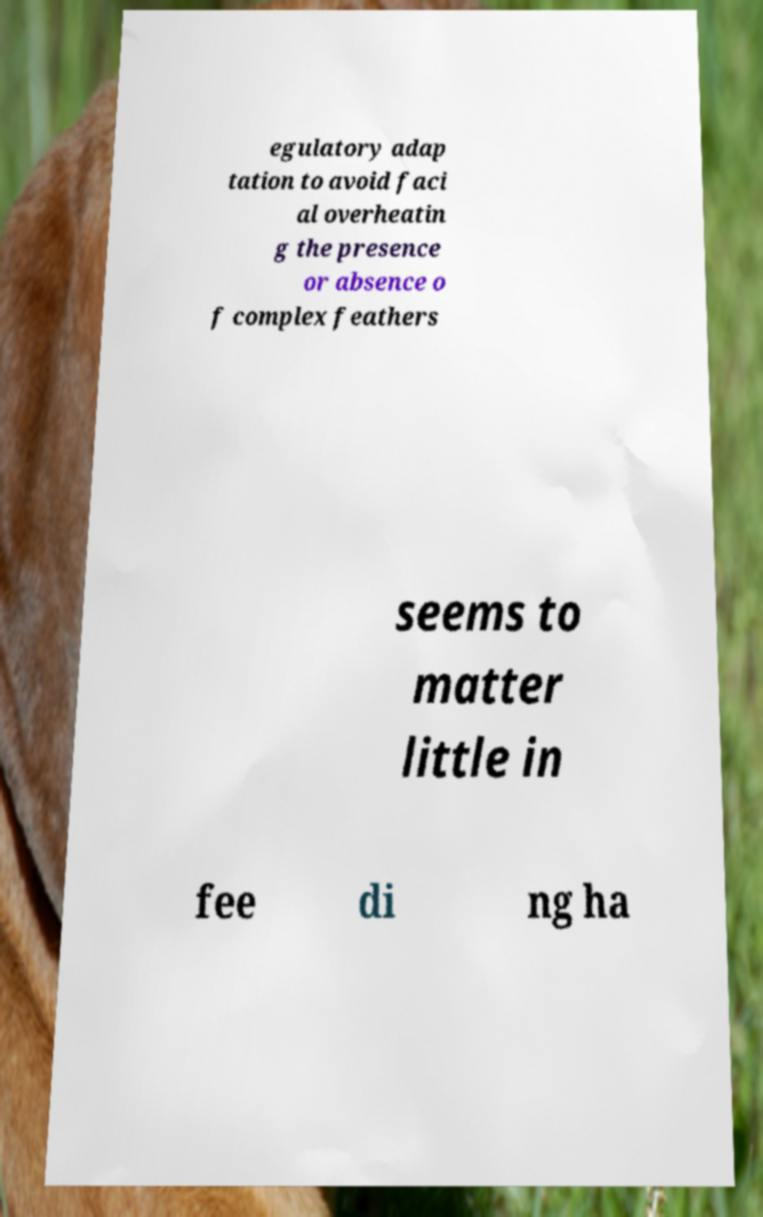For documentation purposes, I need the text within this image transcribed. Could you provide that? egulatory adap tation to avoid faci al overheatin g the presence or absence o f complex feathers seems to matter little in fee di ng ha 